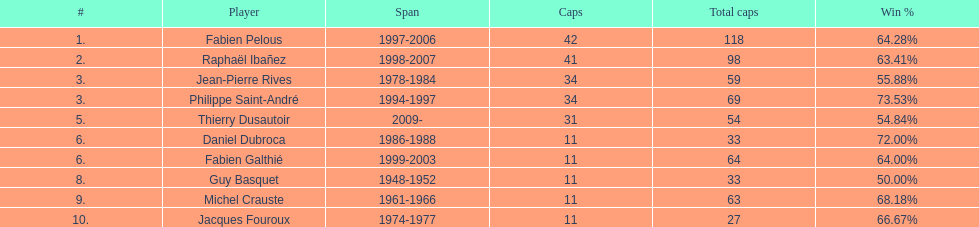Who was the captain with the least time served? Daniel Dubroca. 